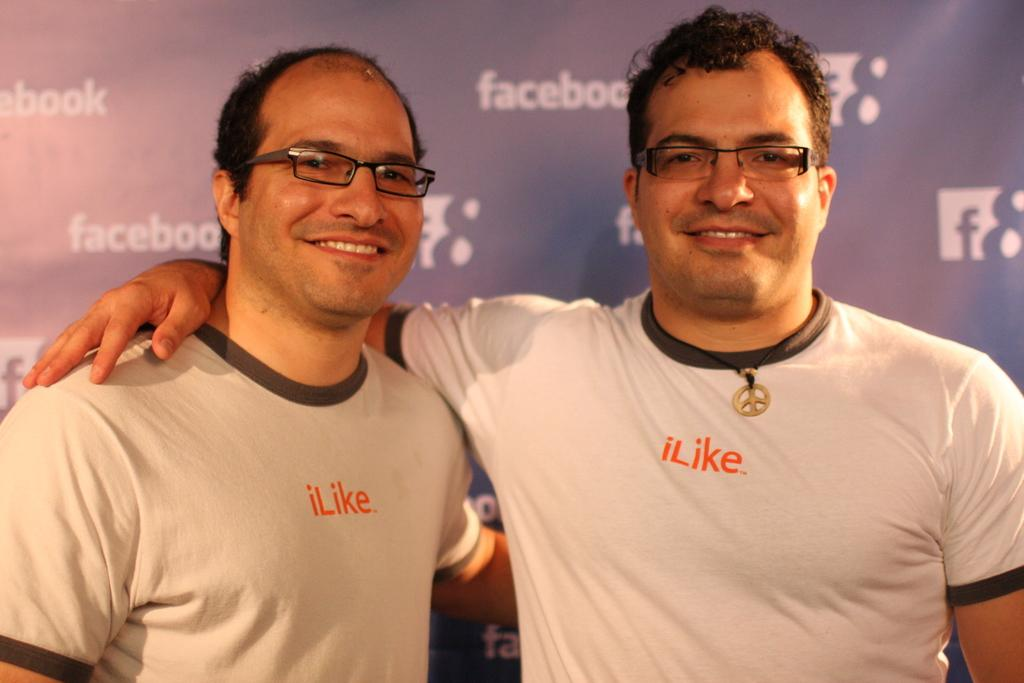How many people are in the image? There are two persons in the image. What is the facial expression of the people in the image? The two persons are smiling. What can be seen on the wall or background in the image? There is a poster in the image. What is written or depicted on the poster? The poster has some text on it. What type of silk fabric is being used by the committee in the image? There is no committee or silk fabric present in the image. Are the two persons in the image sisters? The provided facts do not mention any familial relationship between the two persons, so we cannot definitively answer that question. 